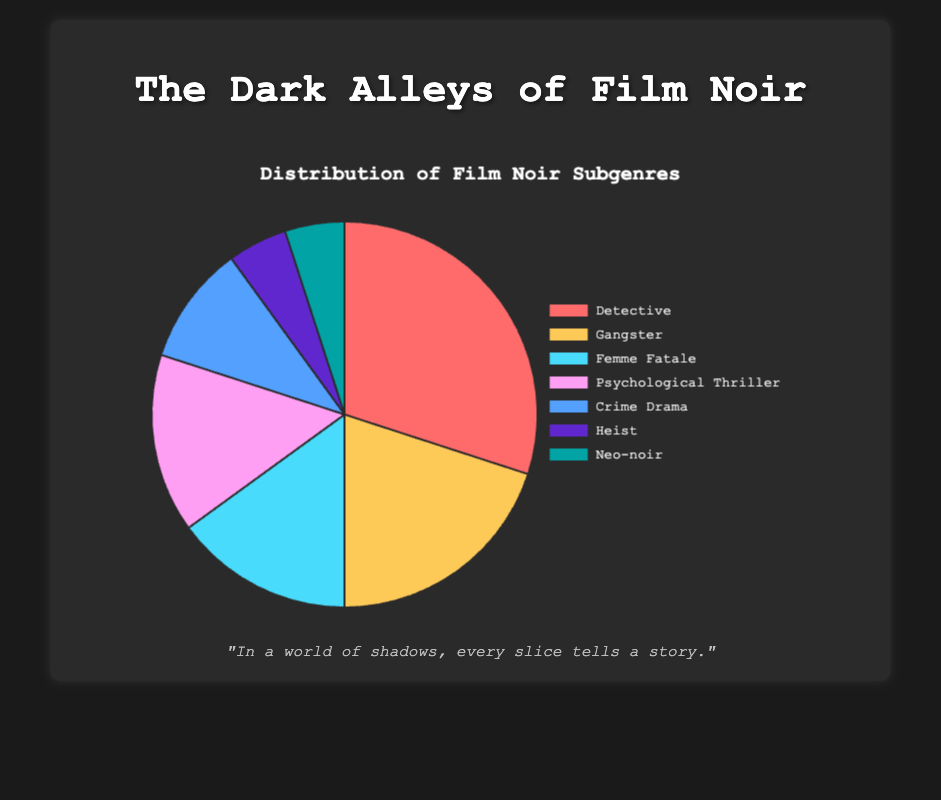Which subgenre has the highest percentage? The subgenre with the highest percentage can be identified by locating the largest slice in the pie chart, which is colored distinctively. The largest slice is labeled "Detective" with a corresponding percentage of 30%.
Answer: Detective Which subgenres are tied in percentage? To find the subgenres with equal percentages, look for slices of the same size in the pie chart. Both "Femme Fatale" and "Psychological Thriller" have equal shares, each representing 15%.
Answer: Femme Fatale and Psychological Thriller What percentage of the chart is represented by "Gangster" and "Heist" combined? Add the percentages of "Gangster" (20%) and "Heist" (5%). The combined percentage is 20% + 5% = 25%.
Answer: 25% Which subgenre has the smallest representation in the pie chart? The smallest slice in the pie chart indicates the subgenre with the smallest percentage. The slice for "Heist" and "Neo-noir" are the smallest, each representing 5%.
Answer: Heist and Neo-noir How much larger is the "Detective" subgenre compared to the "Crime Drama" subgenre? Subtract the percentage of "Crime Drama" (10%) from "Detective" (30%). The difference is 30% - 10% = 20%.
Answer: 20% Which subgenres together make up half of the distribution? Determine combinations of subgenres whose percentages sum to 50%. "Detective" (30%) + "Gangster" (20%) together make up 50%.
Answer: Detective and Gangster What is the average percentage of the "Detective", "Gangster", and "Femme Fatale" subgenres? Find the average by summing the percentages of "Detective" (30%), "Gangster" (20%), and "Femme Fatale" (15%), then divide by 3. (30% + 20% + 15%) / 3 = 65% / 3 ≈ 21.67%
Answer: 21.67% What is the collective percentage of all the subgenres except "Detective"? Subtract the percentage of "Detective" from the total 100%. 100% - 30% = 70%.
Answer: 70% Which subgenre is represented by the cyan slice? Identify the slice by its color in the chart. The cyan slice corresponds to "Femme Fatale" with a percentage of 15%.
Answer: Femme Fatale 